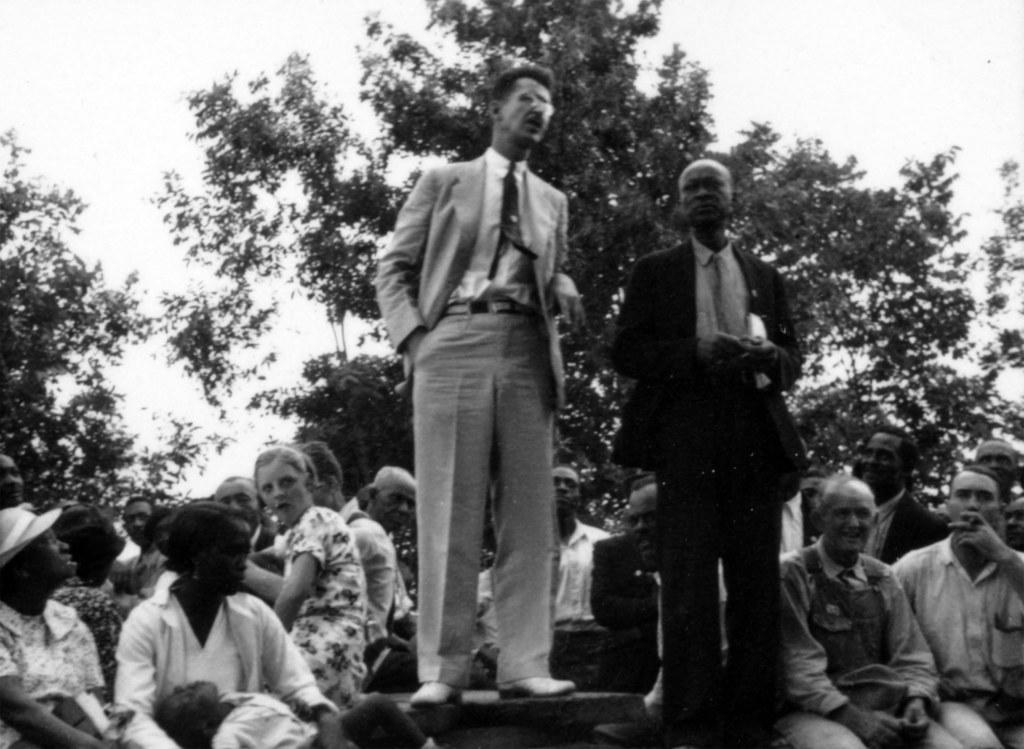What is the color scheme of the image? The image is black and white. How many people are standing in the image? There are two persons standing in the image. Are there any people sitting in the image? Yes, some people are sitting in the image. What can be seen in the background of the image? There are trees and the sky visible in the background of the image. What type of advertisement can be seen on the map in the image? There is no map or advertisement present in the image. How many boats are docked at the harbor in the image? There is no harbor present in the image. 